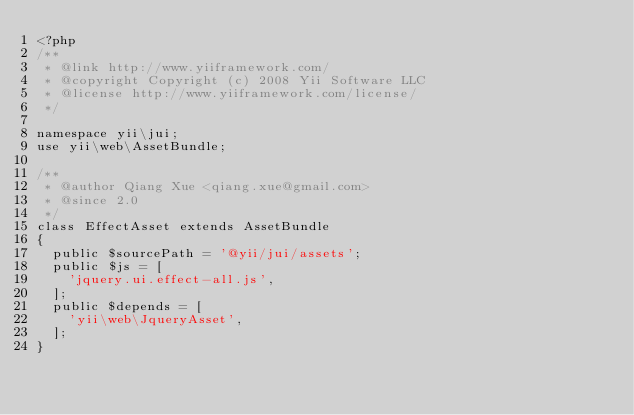Convert code to text. <code><loc_0><loc_0><loc_500><loc_500><_PHP_><?php
/**
 * @link http://www.yiiframework.com/
 * @copyright Copyright (c) 2008 Yii Software LLC
 * @license http://www.yiiframework.com/license/
 */

namespace yii\jui;
use yii\web\AssetBundle;

/**
 * @author Qiang Xue <qiang.xue@gmail.com>
 * @since 2.0
 */
class EffectAsset extends AssetBundle
{
	public $sourcePath = '@yii/jui/assets';
	public $js = [
		'jquery.ui.effect-all.js',
	];
	public $depends = [
		'yii\web\JqueryAsset',
	];
}
</code> 